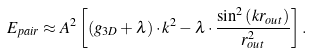Convert formula to latex. <formula><loc_0><loc_0><loc_500><loc_500>E _ { p a i r } \approx A ^ { 2 } \left [ \left ( g _ { 3 D } + \lambda \right ) \cdot k ^ { 2 } - \lambda \cdot \frac { \sin ^ { 2 } \left ( k r _ { o u t } \right ) } { r _ { o u t } ^ { 2 } } \right ] .</formula> 